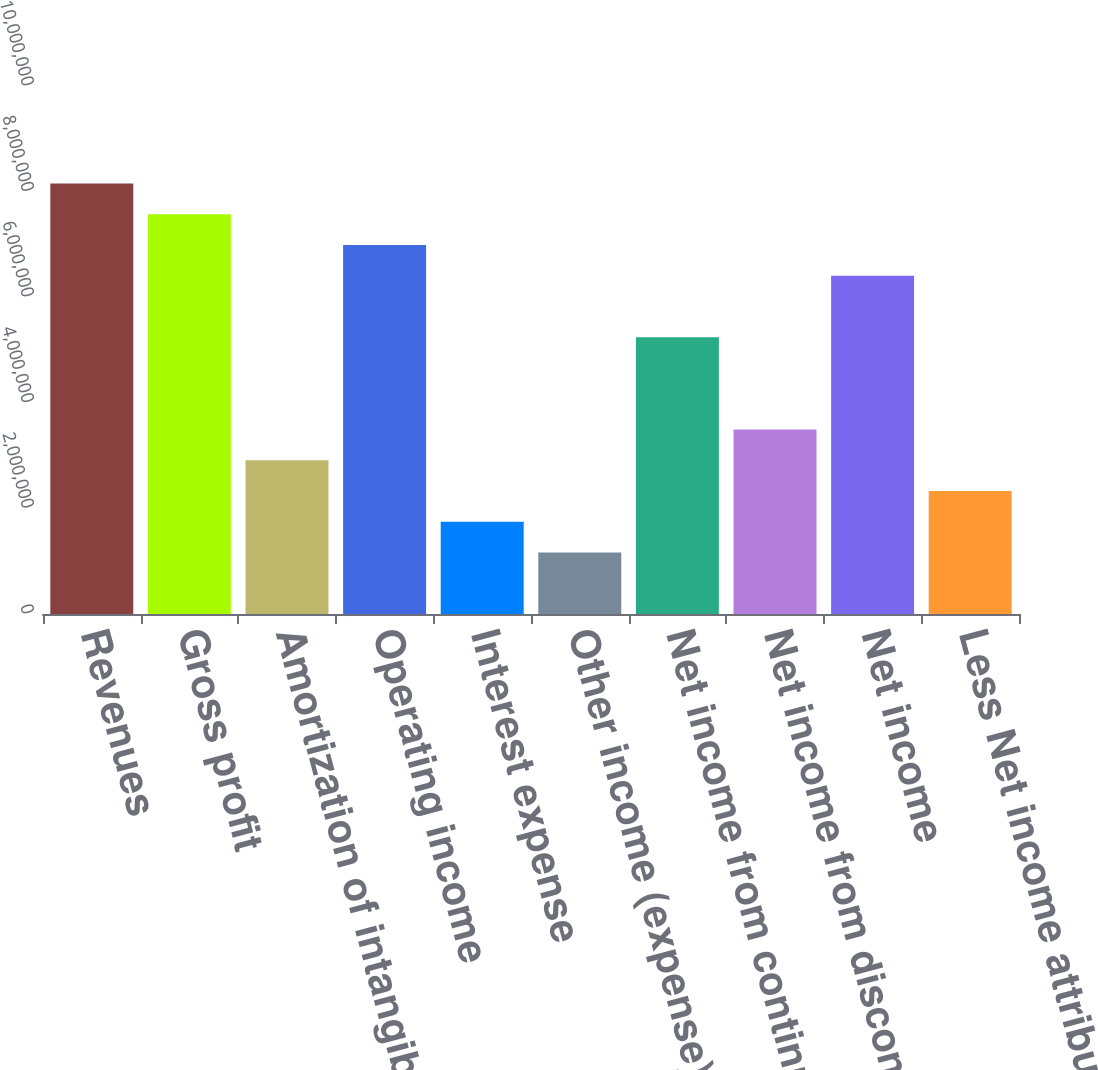Convert chart. <chart><loc_0><loc_0><loc_500><loc_500><bar_chart><fcel>Revenues<fcel>Gross profit<fcel>Amortization of intangible<fcel>Operating income<fcel>Interest expense<fcel>Other income (expense) net<fcel>Net income from continuing<fcel>Net income from discontinued<fcel>Net income<fcel>Less Net income attributable<nl><fcel>8.15512e+06<fcel>7.57261e+06<fcel>2.91254e+06<fcel>6.9901e+06<fcel>1.74753e+06<fcel>1.16502e+06<fcel>5.24258e+06<fcel>3.49505e+06<fcel>6.40759e+06<fcel>2.33003e+06<nl></chart> 